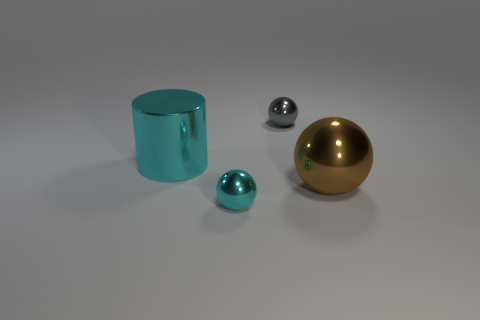Subtract all large brown spheres. How many spheres are left? 2 Add 1 red matte objects. How many objects exist? 5 Subtract all green balls. Subtract all gray cylinders. How many balls are left? 3 Subtract all spheres. How many objects are left? 1 Subtract all cyan metallic things. Subtract all small cyan metallic objects. How many objects are left? 1 Add 4 big metal spheres. How many big metal spheres are left? 5 Add 1 small red matte spheres. How many small red matte spheres exist? 1 Subtract 0 green balls. How many objects are left? 4 